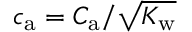<formula> <loc_0><loc_0><loc_500><loc_500>{ c _ { a } = C _ { a } / \sqrt { K _ { w } } }</formula> 